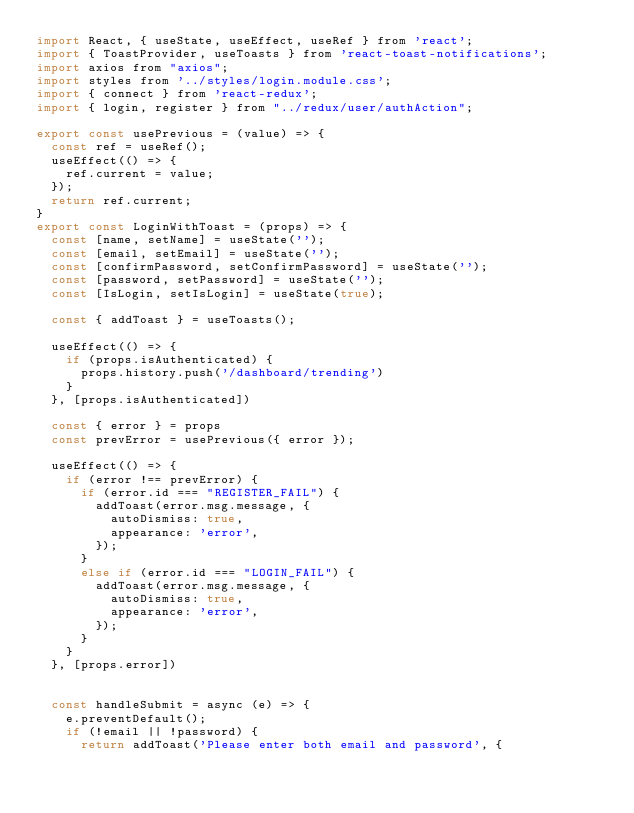Convert code to text. <code><loc_0><loc_0><loc_500><loc_500><_JavaScript_>import React, { useState, useEffect, useRef } from 'react';
import { ToastProvider, useToasts } from 'react-toast-notifications';
import axios from "axios";
import styles from '../styles/login.module.css';
import { connect } from 'react-redux';
import { login, register } from "../redux/user/authAction";

export const usePrevious = (value) => {
  const ref = useRef();
  useEffect(() => {
    ref.current = value;
  });
  return ref.current;
}
export const LoginWithToast = (props) => {
  const [name, setName] = useState('');
  const [email, setEmail] = useState('');
  const [confirmPassword, setConfirmPassword] = useState('');
  const [password, setPassword] = useState('');
  const [IsLogin, setIsLogin] = useState(true);

  const { addToast } = useToasts();

  useEffect(() => {
    if (props.isAuthenticated) {
      props.history.push('/dashboard/trending')
    }
  }, [props.isAuthenticated])

  const { error } = props
  const prevError = usePrevious({ error });

  useEffect(() => {
    if (error !== prevError) {
      if (error.id === "REGISTER_FAIL") {
        addToast(error.msg.message, {
          autoDismiss: true,
          appearance: 'error',
        });
      }
      else if (error.id === "LOGIN_FAIL") {
        addToast(error.msg.message, {
          autoDismiss: true,
          appearance: 'error',
        });
      }
    }
  }, [props.error])


  const handleSubmit = async (e) => {
    e.preventDefault();
    if (!email || !password) {
      return addToast('Please enter both email and password', {</code> 